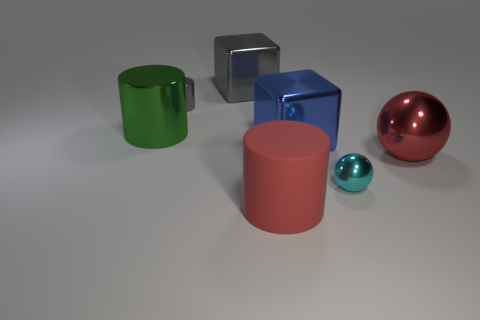The big rubber thing has what shape?
Make the answer very short. Cylinder. There is a gray thing that is the same size as the cyan shiny ball; what material is it?
Your answer should be compact. Metal. Is there anything else that is the same size as the red sphere?
Provide a succinct answer. Yes. What number of objects are large purple metallic cylinders or large cubes that are left of the large rubber object?
Offer a very short reply. 1. There is a cyan sphere that is the same material as the large gray block; what size is it?
Offer a very short reply. Small. What shape is the red object that is to the left of the tiny object to the right of the tiny gray metal object?
Offer a very short reply. Cylinder. What size is the cylinder that is both in front of the tiny gray cylinder and behind the tiny sphere?
Your response must be concise. Large. Is there a big matte thing that has the same shape as the tiny cyan thing?
Ensure brevity in your answer.  No. Are there any other things that have the same shape as the blue object?
Give a very brief answer. Yes. What material is the tiny object left of the cylinder that is in front of the tiny metallic thing to the right of the big gray block?
Offer a very short reply. Metal. 